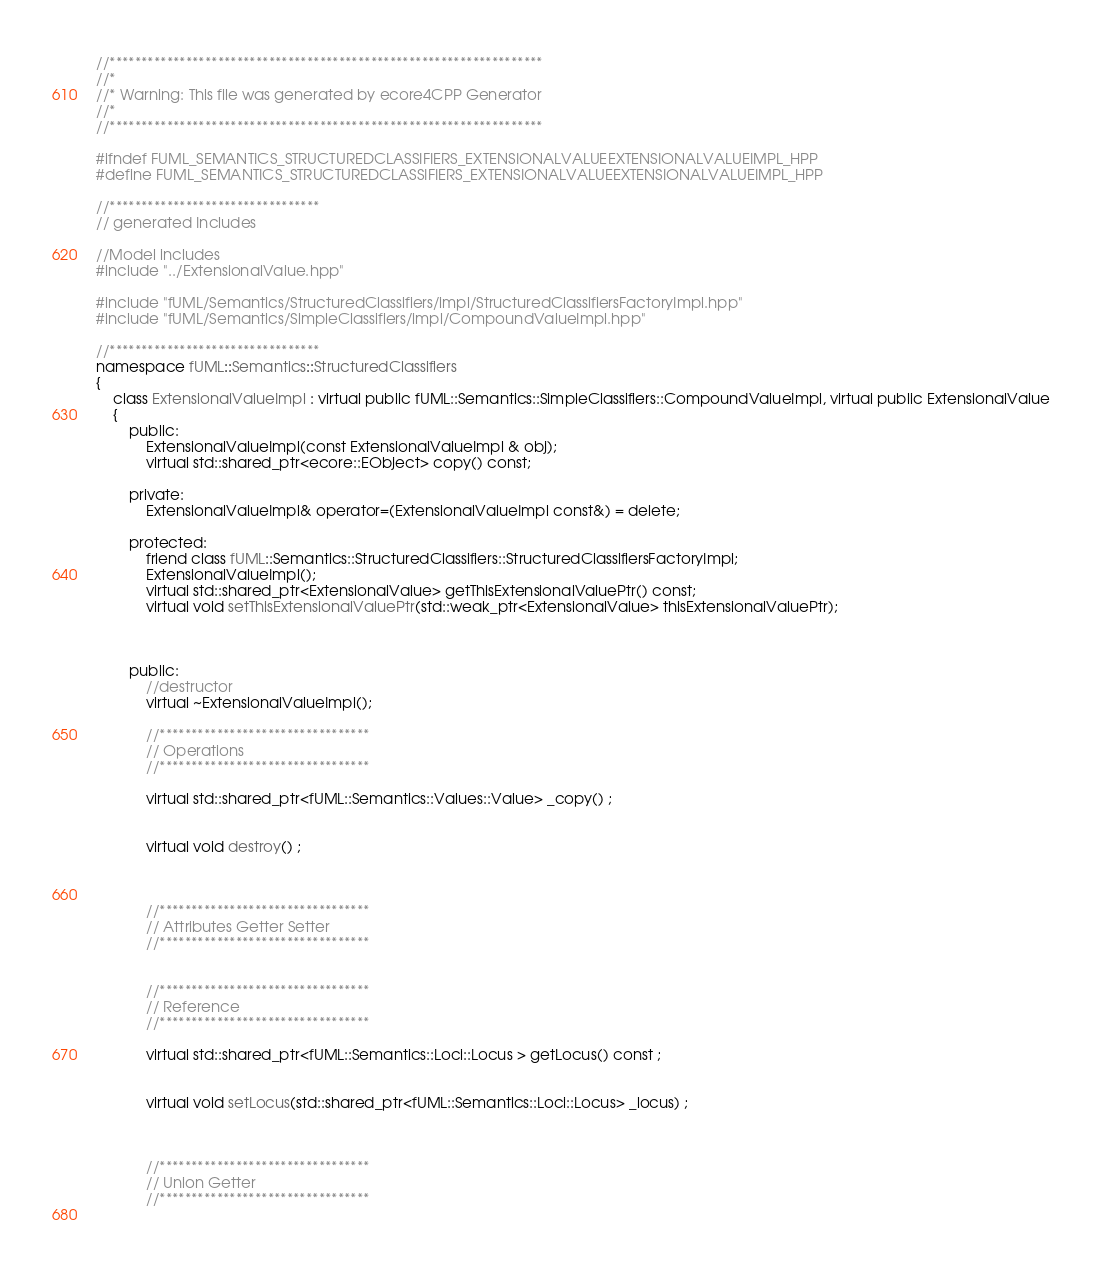Convert code to text. <code><loc_0><loc_0><loc_500><loc_500><_C++_>//********************************************************************
//*    
//* Warning: This file was generated by ecore4CPP Generator
//*
//********************************************************************

#ifndef FUML_SEMANTICS_STRUCTUREDCLASSIFIERS_EXTENSIONALVALUEEXTENSIONALVALUEIMPL_HPP
#define FUML_SEMANTICS_STRUCTUREDCLASSIFIERS_EXTENSIONALVALUEEXTENSIONALVALUEIMPL_HPP

//*********************************
// generated Includes

//Model includes
#include "../ExtensionalValue.hpp"

#include "fUML/Semantics/StructuredClassifiers/impl/StructuredClassifiersFactoryImpl.hpp"
#include "fUML/Semantics/SimpleClassifiers/impl/CompoundValueImpl.hpp"

//*********************************
namespace fUML::Semantics::StructuredClassifiers 
{
	class ExtensionalValueImpl : virtual public fUML::Semantics::SimpleClassifiers::CompoundValueImpl, virtual public ExtensionalValue 
	{
		public: 
			ExtensionalValueImpl(const ExtensionalValueImpl & obj);
			virtual std::shared_ptr<ecore::EObject> copy() const;

		private:    
			ExtensionalValueImpl& operator=(ExtensionalValueImpl const&) = delete;

		protected:
			friend class fUML::Semantics::StructuredClassifiers::StructuredClassifiersFactoryImpl;
			ExtensionalValueImpl();
			virtual std::shared_ptr<ExtensionalValue> getThisExtensionalValuePtr() const;
			virtual void setThisExtensionalValuePtr(std::weak_ptr<ExtensionalValue> thisExtensionalValuePtr);



		public:
			//destructor
			virtual ~ExtensionalValueImpl();
			
			//*********************************
			// Operations
			//*********************************
			 
			virtual std::shared_ptr<fUML::Semantics::Values::Value> _copy() ;
			
			 
			virtual void destroy() ;
			
			
			
			//*********************************
			// Attributes Getter Setter
			//*********************************
			
			
			//*********************************
			// Reference
			//*********************************
			
			virtual std::shared_ptr<fUML::Semantics::Loci::Locus > getLocus() const ;
			
			
			virtual void setLocus(std::shared_ptr<fUML::Semantics::Loci::Locus> _locus) ;
			
							
			
			//*********************************
			// Union Getter
			//*********************************
			 
			 </code> 